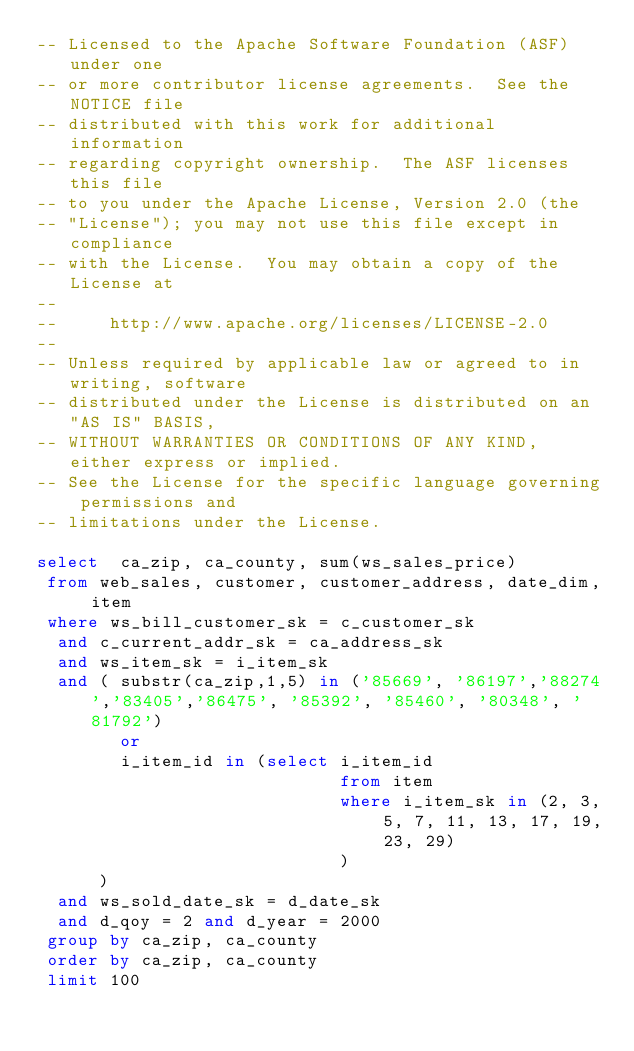<code> <loc_0><loc_0><loc_500><loc_500><_SQL_>-- Licensed to the Apache Software Foundation (ASF) under one
-- or more contributor license agreements.  See the NOTICE file
-- distributed with this work for additional information
-- regarding copyright ownership.  The ASF licenses this file
-- to you under the Apache License, Version 2.0 (the
-- "License"); you may not use this file except in compliance
-- with the License.  You may obtain a copy of the License at
--
--     http://www.apache.org/licenses/LICENSE-2.0
--
-- Unless required by applicable law or agreed to in writing, software
-- distributed under the License is distributed on an "AS IS" BASIS,
-- WITHOUT WARRANTIES OR CONDITIONS OF ANY KIND, either express or implied.
-- See the License for the specific language governing permissions and
-- limitations under the License.

select  ca_zip, ca_county, sum(ws_sales_price)
 from web_sales, customer, customer_address, date_dim, item
 where ws_bill_customer_sk = c_customer_sk
 	and c_current_addr_sk = ca_address_sk 
 	and ws_item_sk = i_item_sk 
 	and ( substr(ca_zip,1,5) in ('85669', '86197','88274','83405','86475', '85392', '85460', '80348', '81792')
 	      or 
 	      i_item_id in (select i_item_id
                             from item
                             where i_item_sk in (2, 3, 5, 7, 11, 13, 17, 19, 23, 29)
                             )
 	    )
 	and ws_sold_date_sk = d_date_sk
 	and d_qoy = 2 and d_year = 2000
 group by ca_zip, ca_county
 order by ca_zip, ca_county
 limit 100
</code> 